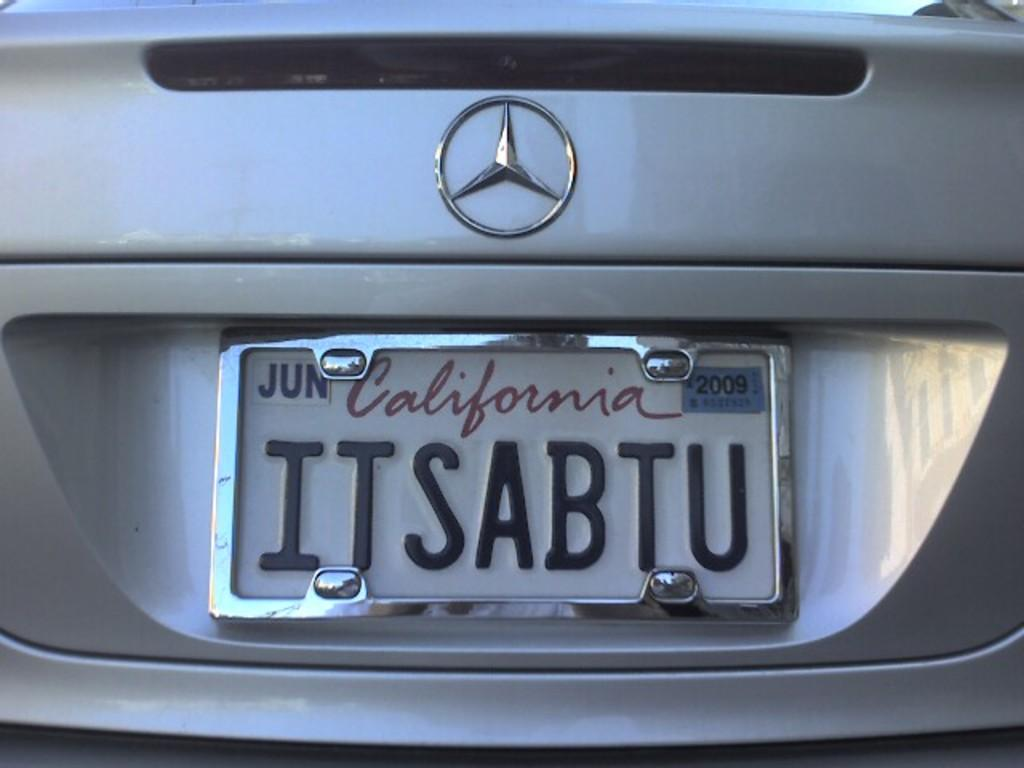<image>
Render a clear and concise summary of the photo. the word California is on a license plate 